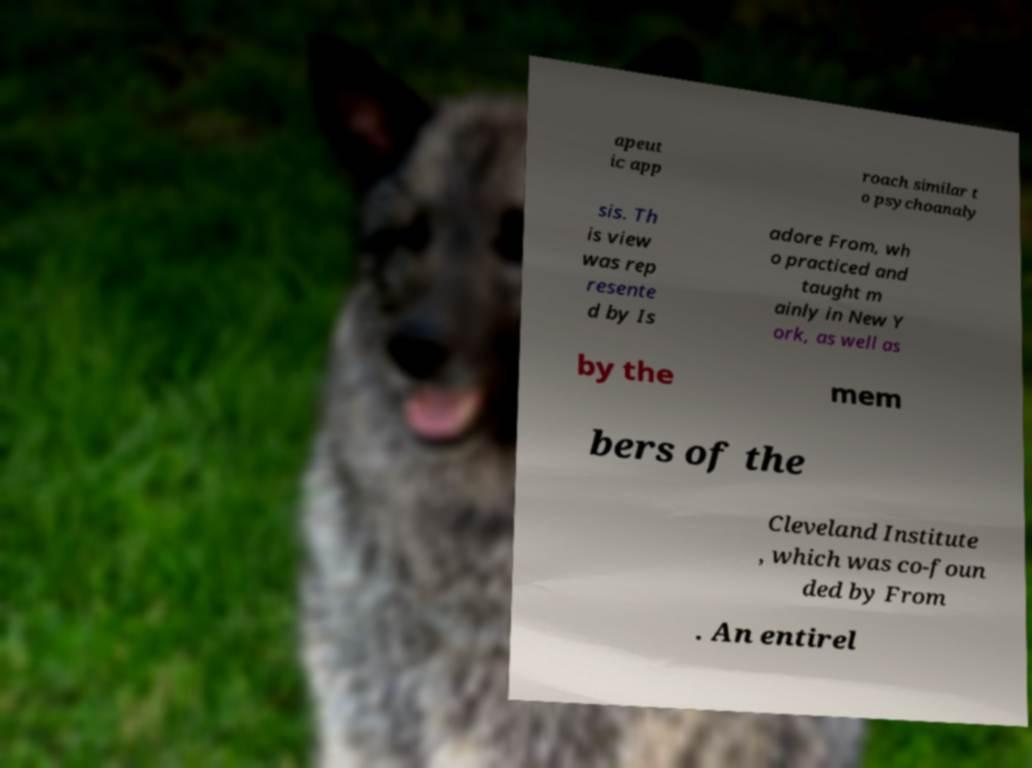I need the written content from this picture converted into text. Can you do that? apeut ic app roach similar t o psychoanaly sis. Th is view was rep resente d by Is adore From, wh o practiced and taught m ainly in New Y ork, as well as by the mem bers of the Cleveland Institute , which was co-foun ded by From . An entirel 